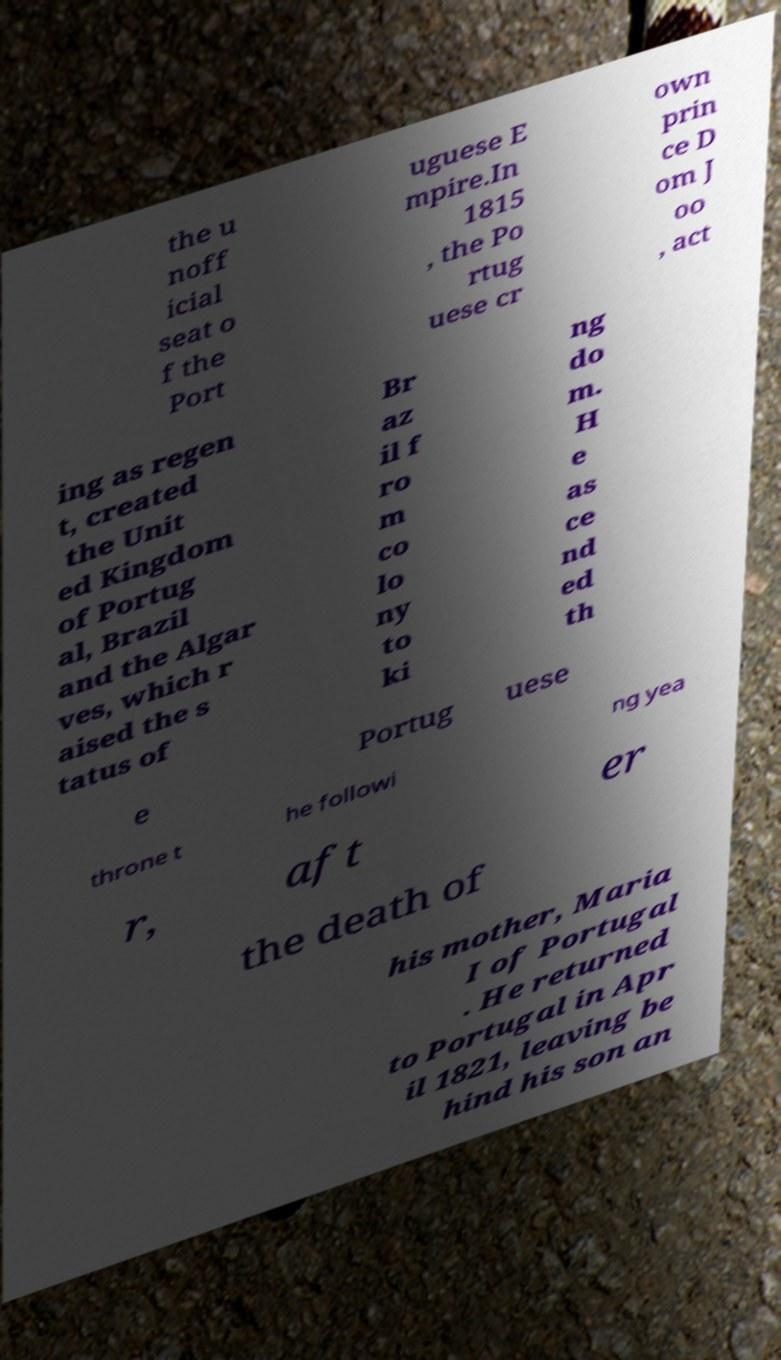Can you read and provide the text displayed in the image?This photo seems to have some interesting text. Can you extract and type it out for me? the u noff icial seat o f the Port uguese E mpire.In 1815 , the Po rtug uese cr own prin ce D om J oo , act ing as regen t, created the Unit ed Kingdom of Portug al, Brazil and the Algar ves, which r aised the s tatus of Br az il f ro m co lo ny to ki ng do m. H e as ce nd ed th e Portug uese throne t he followi ng yea r, aft er the death of his mother, Maria I of Portugal . He returned to Portugal in Apr il 1821, leaving be hind his son an 